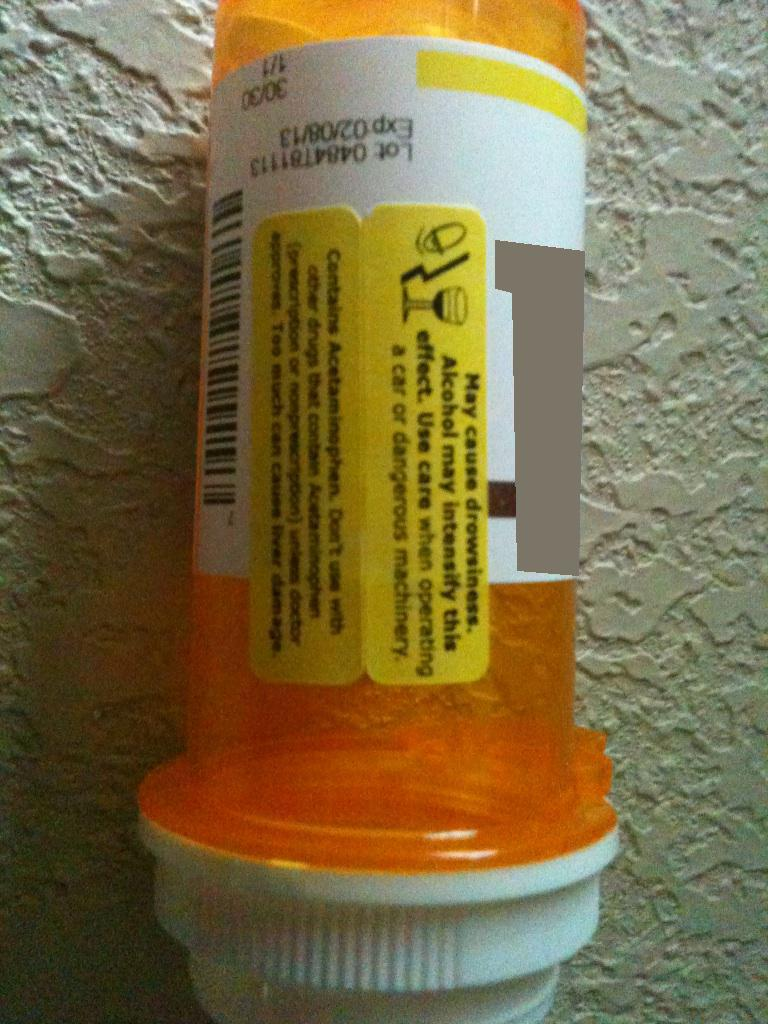Imagine an adventurous scenario where misreading this label leads to an unexpected journey. A misreading of the warning label led Alex to a peculiar day. Without realizing, they took their medication, grabbed a quick shower, and headed out to meet some friends. It was only an hour into the drive through an enchanting forest that Alex felt the waves of drowsiness kicking in. The trees appeared larger, the colors more vivid, almost inviting. Parking off the road, Alex decided a quick nap wouldn’t hurt. Waking up, they found themselves amidst a vibrant carnival with whimsical characters beckoning them. Could it be a dream or the onset of vivid imaginations? The cautionary advice on the label now seemed more significant as Alex navigated this fantastical realm, each step blending reality and fantasy in a thrilling adventure. 